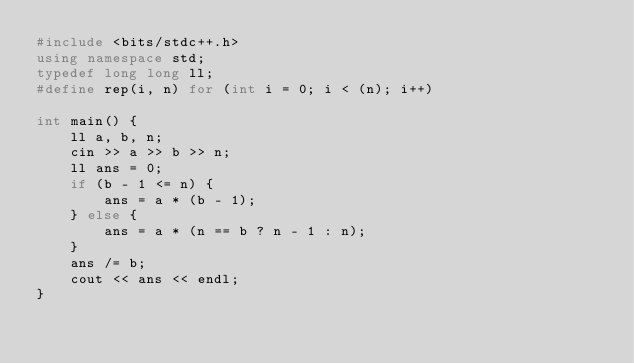<code> <loc_0><loc_0><loc_500><loc_500><_C++_>#include <bits/stdc++.h>
using namespace std;
typedef long long ll;
#define rep(i, n) for (int i = 0; i < (n); i++)

int main() {
    ll a, b, n;
    cin >> a >> b >> n;
    ll ans = 0;
    if (b - 1 <= n) {
        ans = a * (b - 1);
    } else {
        ans = a * (n == b ? n - 1 : n);
    }
    ans /= b;
    cout << ans << endl;
}</code> 